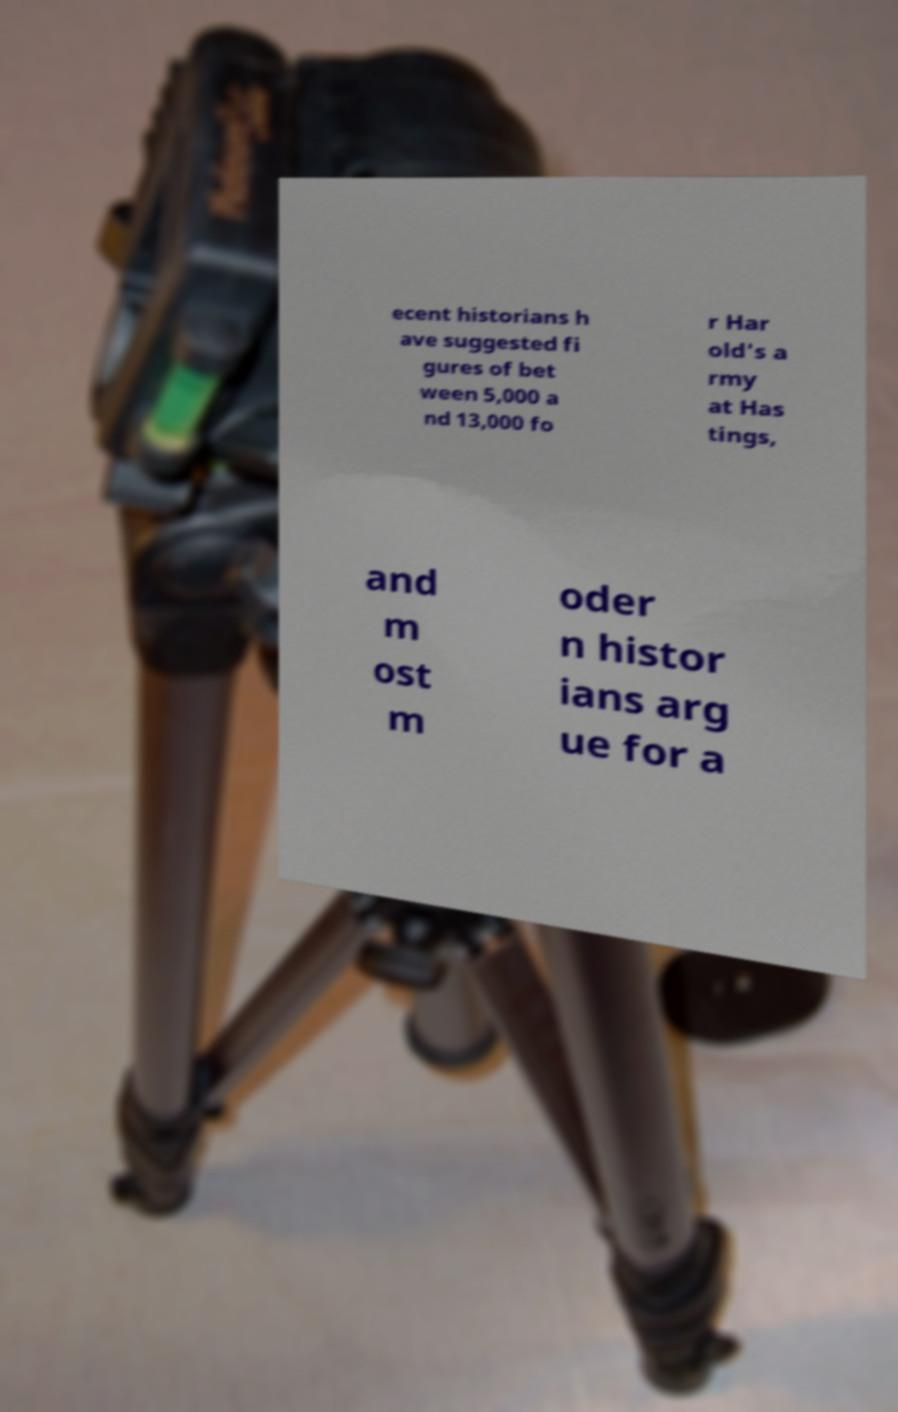Can you accurately transcribe the text from the provided image for me? ecent historians h ave suggested fi gures of bet ween 5,000 a nd 13,000 fo r Har old's a rmy at Has tings, and m ost m oder n histor ians arg ue for a 